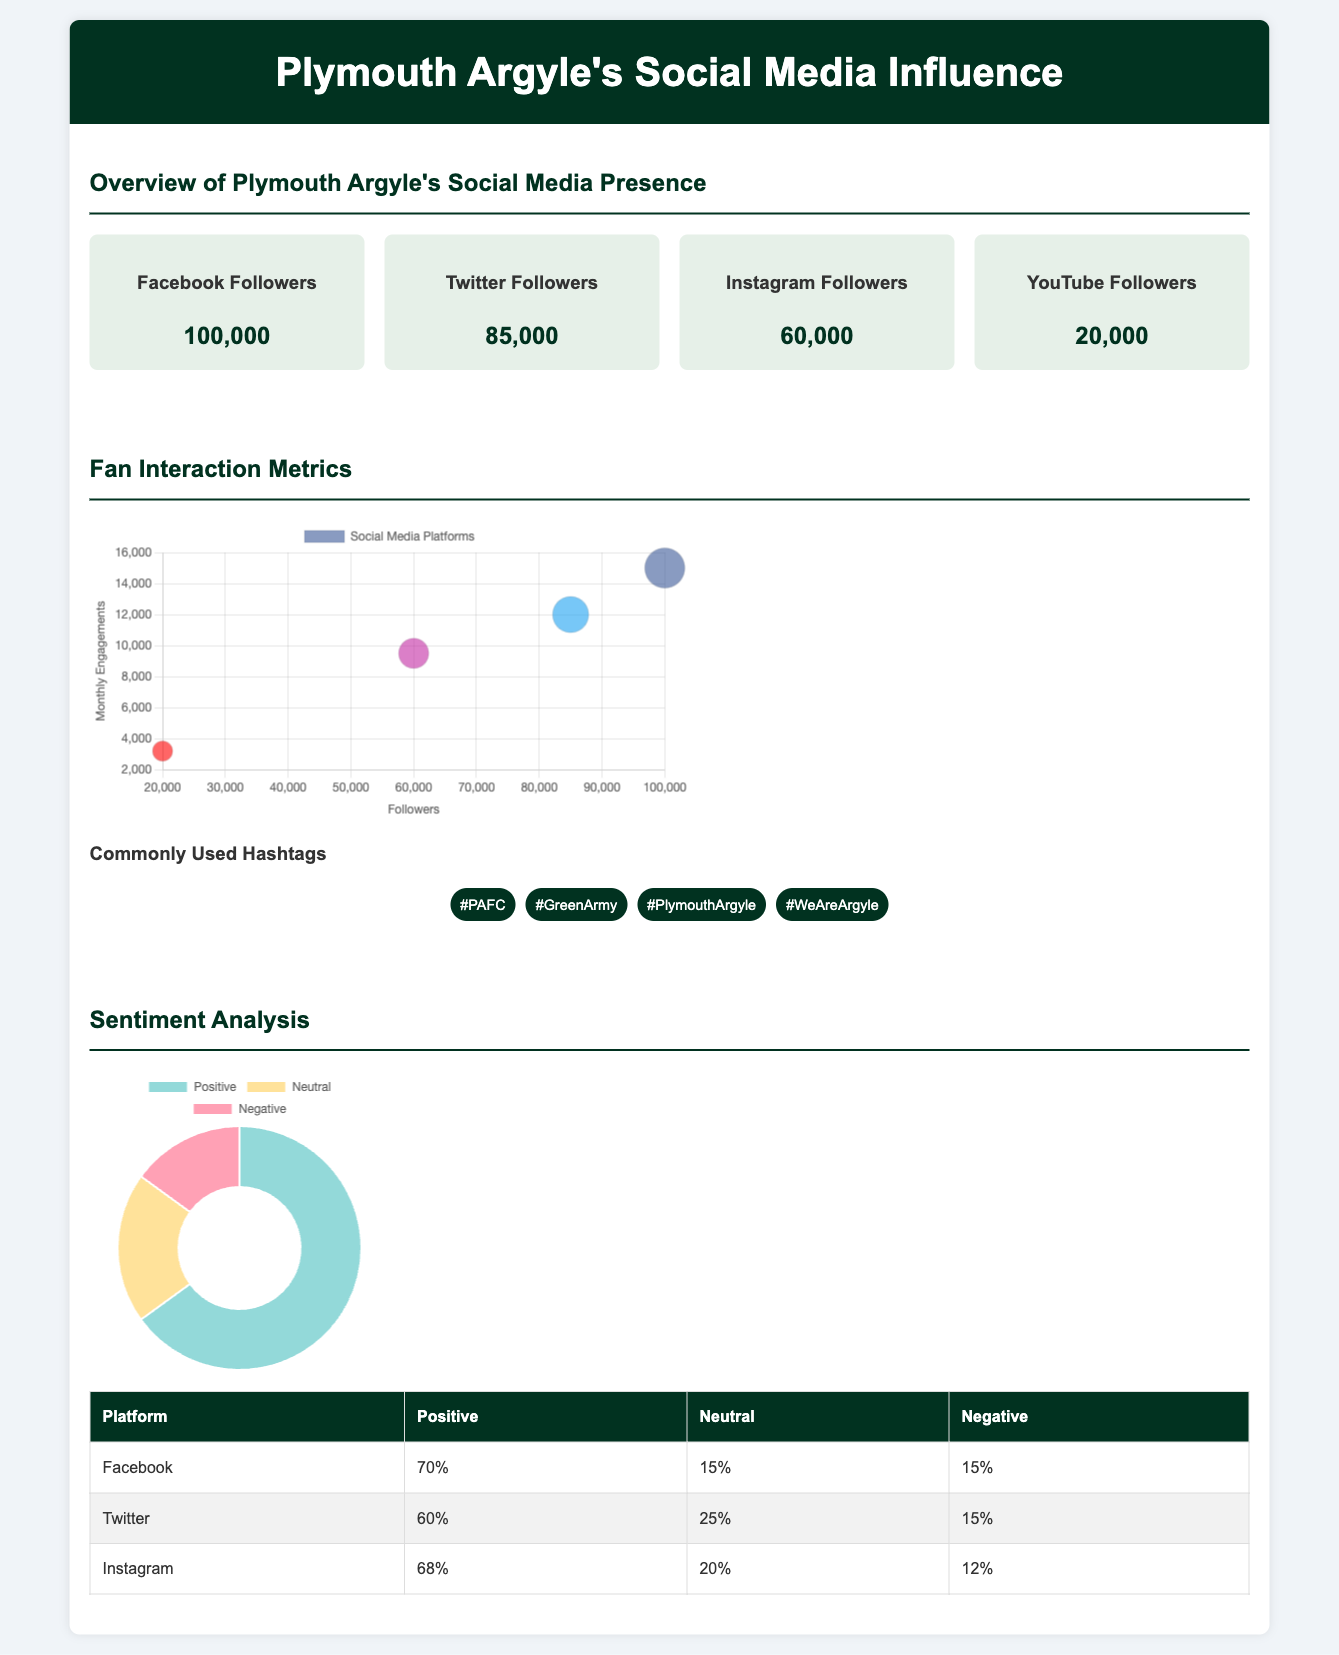What is the number of Facebook followers? The document lists the number of Facebook followers for Plymouth Argyle as 100,000.
Answer: 100,000 What is the sentiment percentage for Instagram? The document indicates that 68% of interactions on Instagram are positive.
Answer: 68% Which social media platform has the highest follower count? According to the document, Facebook has the highest follower count at 100,000 followers.
Answer: Facebook What is the monthly engagement for Twitter? The bubble chart indicates that Twitter has 12,000 monthly engagements.
Answer: 12,000 What is the ratio of negative sentiment on Facebook? The document states that the negative sentiment on Facebook is 15%.
Answer: 15% Which commonly used hashtag is associated with Plymouth Argyle? The document lists several hashtags, including #PAFC, which is commonly used.
Answer: #PAFC How many total social media platforms are listed in the document? There are four social media platforms mentioned in the document: Facebook, Twitter, Instagram, and YouTube.
Answer: Four What is the total engagement figure for high follower count platforms? The bubble chart indicates that the total engagement figure for high follower count platforms is 15,000 (Facebook) + 12,000 (Twitter) = 27,000.
Answer: 27,000 